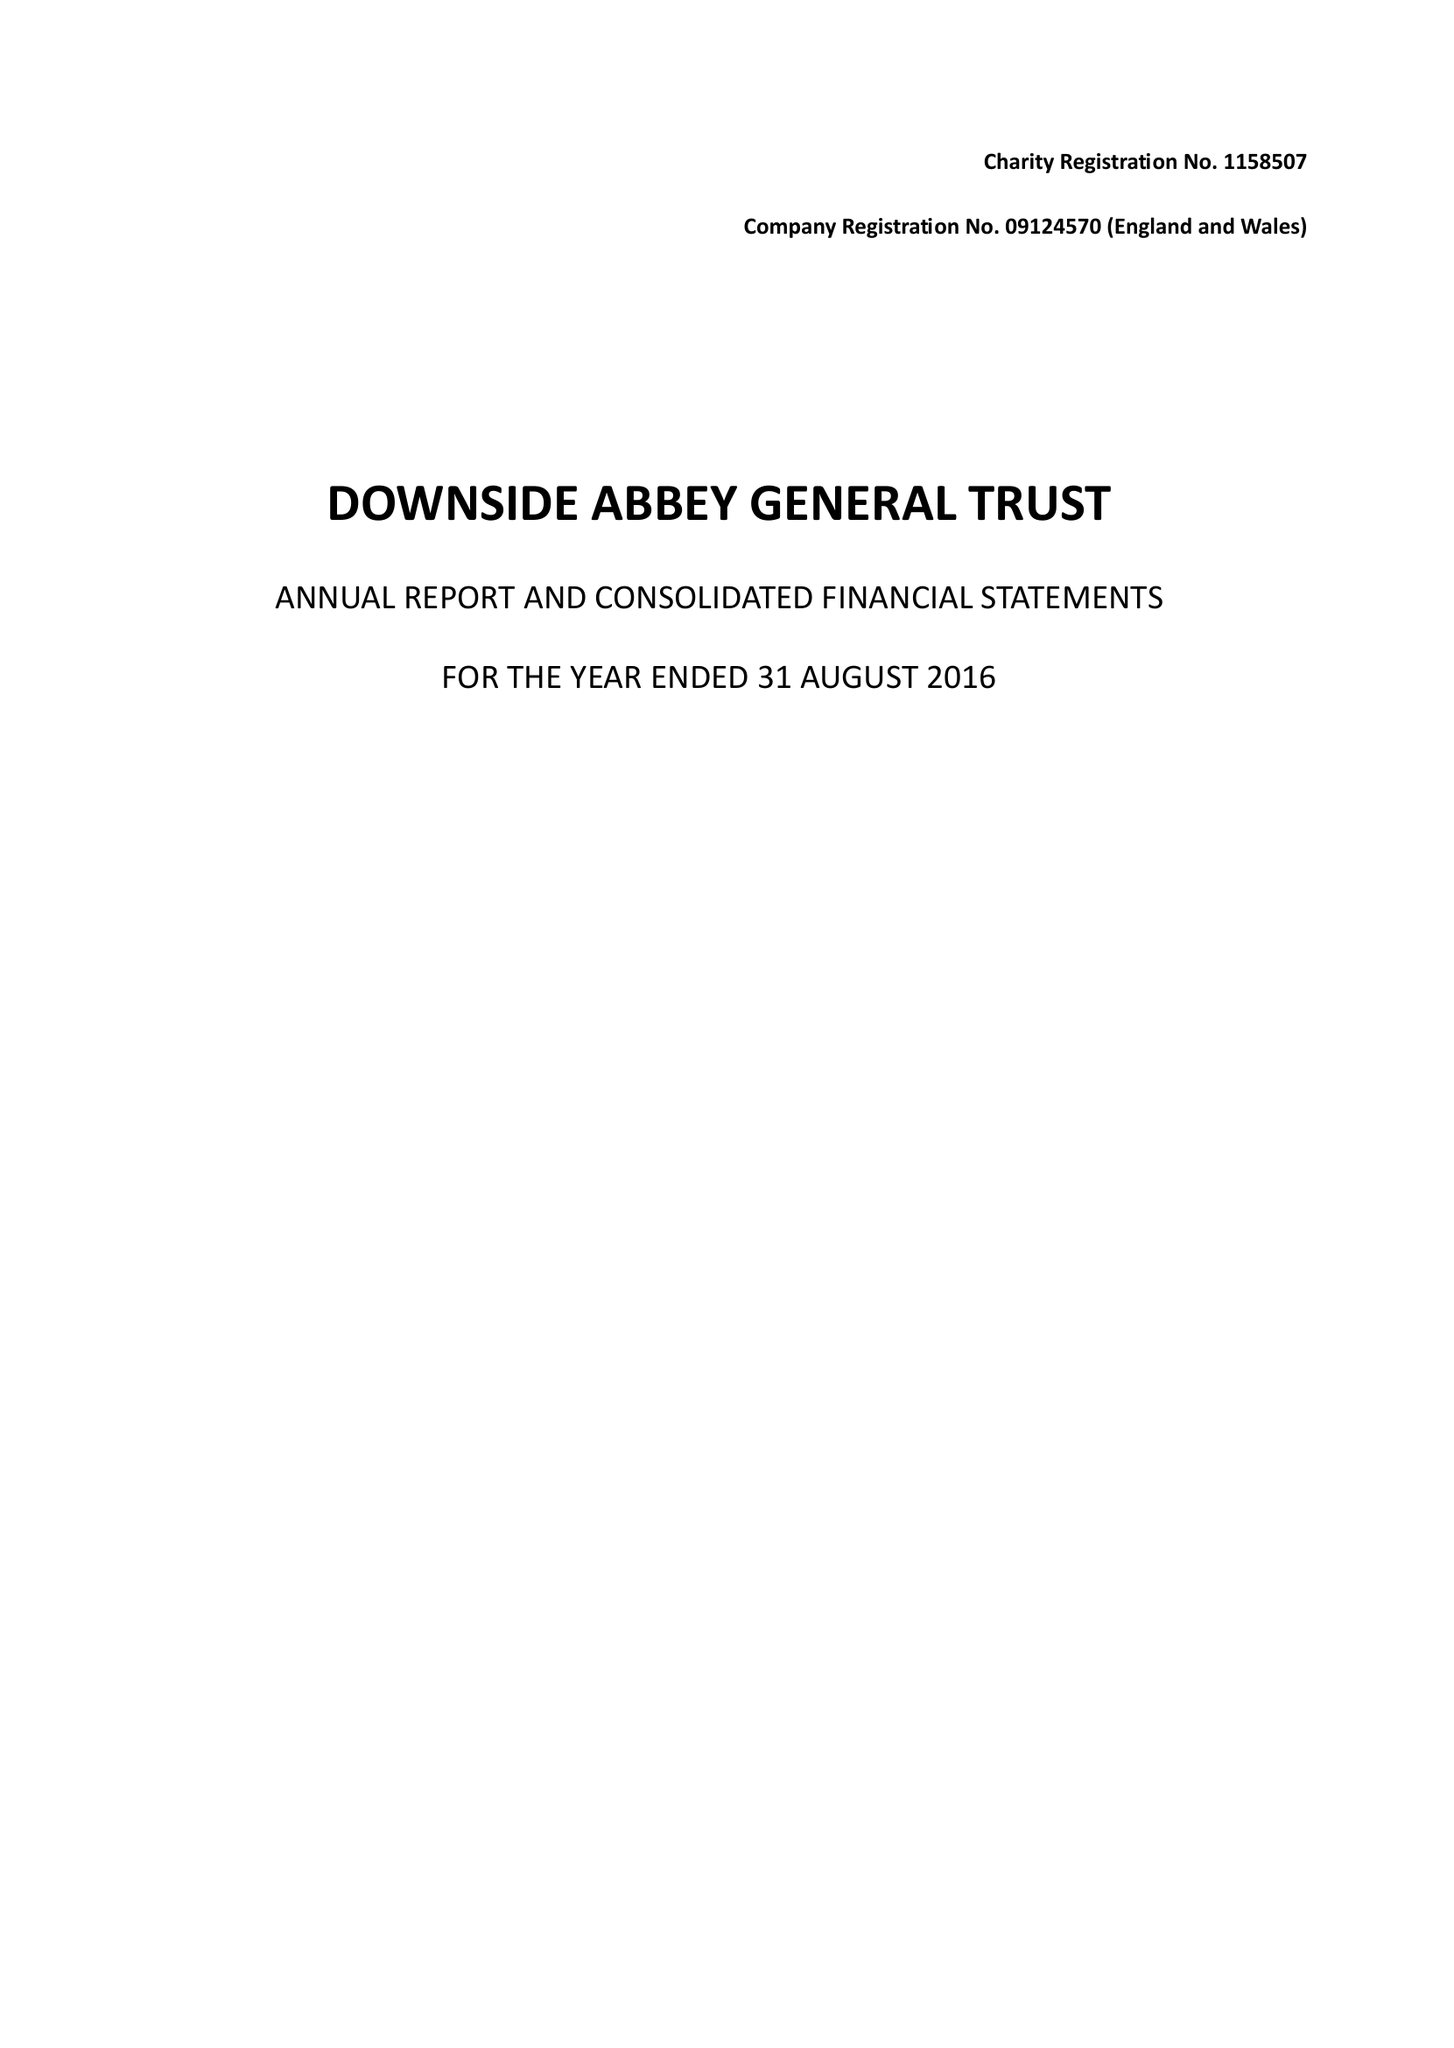What is the value for the address__street_line?
Answer the question using a single word or phrase. None 